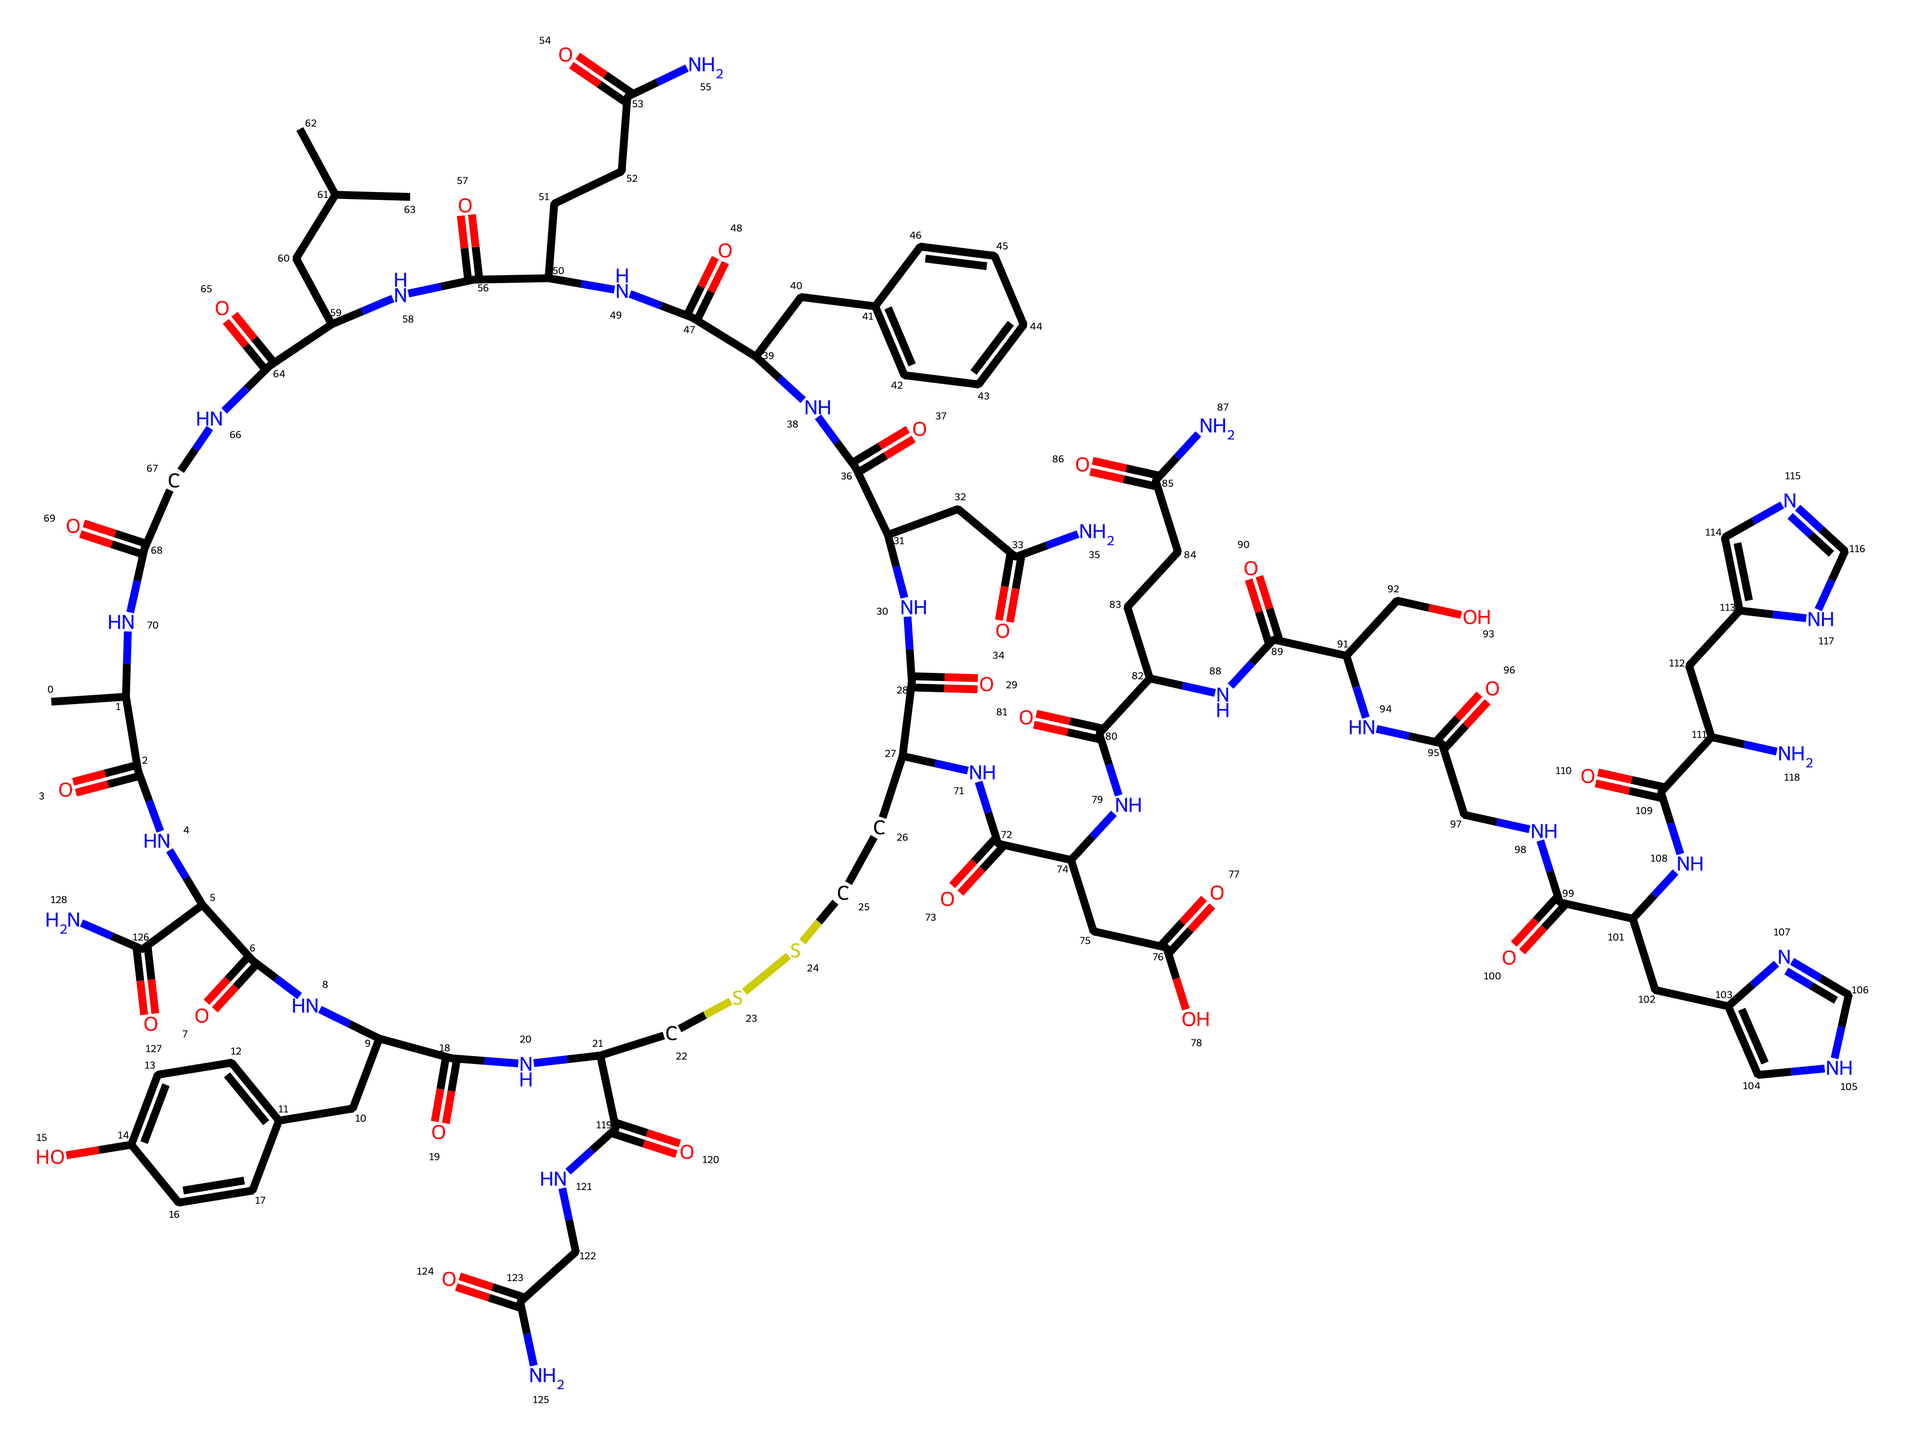What is the molecular formula of oxytocin? To find the molecular formula, we need to count the number of each type of atom in the chemical structure represented by the SMILES notation. After analyzing the structure, we find that there are 9 carbon (C) atoms, 13 hydrogen (H) atoms, 2 nitrogen (N) atoms, and 2 oxygen (O) atoms. Thus, the molecular formula is C9H13N2O2.
Answer: C9H13N2O2 How many rings are present in the structure of oxytocin? Rings in a chemical structure are typically indicated by the presence of ring closures in the SMILES notation. Analyzing the given SMILES, we do not observe any ring formations, as there are no numbers indicating ring closures. Therefore, there are 0 rings in the structure.
Answer: 0 What functional groups are present in oxytocin? Functional groups can be identified by recognizing certain patterns in the molecular structure. The SMILES indicate the presence of amide (C(=O)N), hydroxy (C-OH), and carboxylic acid (C(=O)O) functional groups. Therefore, the main functional groups identified in oxytocin include amide and hydroxy.
Answer: amide, hydroxy, carboxylic acid What is the total number of peptide bonds in the oxytocin structure? Peptide bonds are formed between the carbonyl carbon (C=O) of one amino acid and the nitrogen (N) of another amino acid. By examining the connections in the chemical structure, we can identify that oxytocin contains 1 peptide bond linking its two amino acid residues.
Answer: 1 Which atom is responsible for the biological function of oxytocin? The biological function of oxytocin is primarily mediated by the interaction of the nitrogen atoms (N) with the receptors in the body. These nitrogen atoms play a key role in the binding mechanism for the hormone's activity in physiological functions such as labor induction.
Answer: nitrogen 